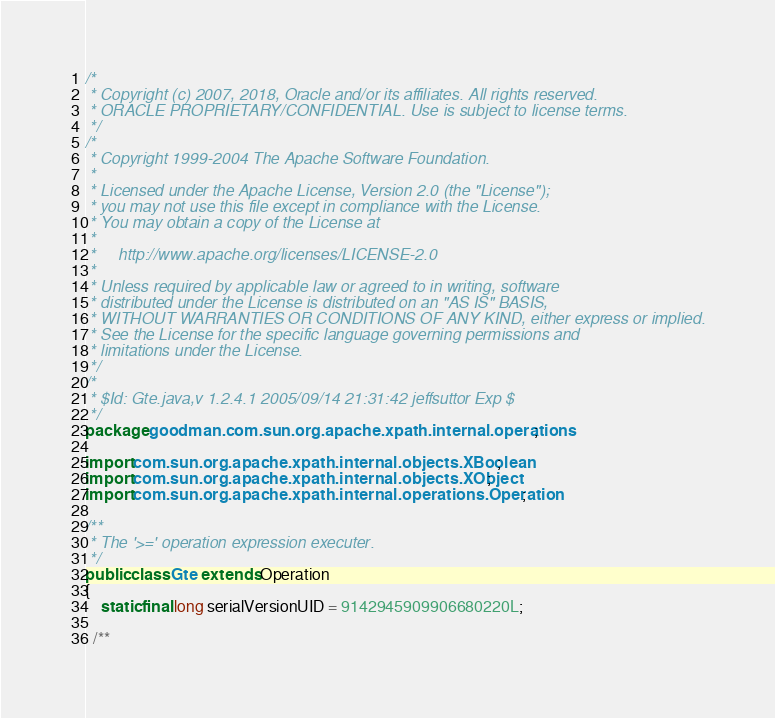Convert code to text. <code><loc_0><loc_0><loc_500><loc_500><_Java_>/*
 * Copyright (c) 2007, 2018, Oracle and/or its affiliates. All rights reserved.
 * ORACLE PROPRIETARY/CONFIDENTIAL. Use is subject to license terms.
 */
/*
 * Copyright 1999-2004 The Apache Software Foundation.
 *
 * Licensed under the Apache License, Version 2.0 (the "License");
 * you may not use this file except in compliance with the License.
 * You may obtain a copy of the License at
 *
 *     http://www.apache.org/licenses/LICENSE-2.0
 *
 * Unless required by applicable law or agreed to in writing, software
 * distributed under the License is distributed on an "AS IS" BASIS,
 * WITHOUT WARRANTIES OR CONDITIONS OF ANY KIND, either express or implied.
 * See the License for the specific language governing permissions and
 * limitations under the License.
 */
/*
 * $Id: Gte.java,v 1.2.4.1 2005/09/14 21:31:42 jeffsuttor Exp $
 */
package goodman.com.sun.org.apache.xpath.internal.operations;

import com.sun.org.apache.xpath.internal.objects.XBoolean;
import com.sun.org.apache.xpath.internal.objects.XObject;
import com.sun.org.apache.xpath.internal.operations.Operation;

/**
 * The '>=' operation expression executer.
 */
public class Gte extends Operation
{
    static final long serialVersionUID = 9142945909906680220L;

  /**</code> 